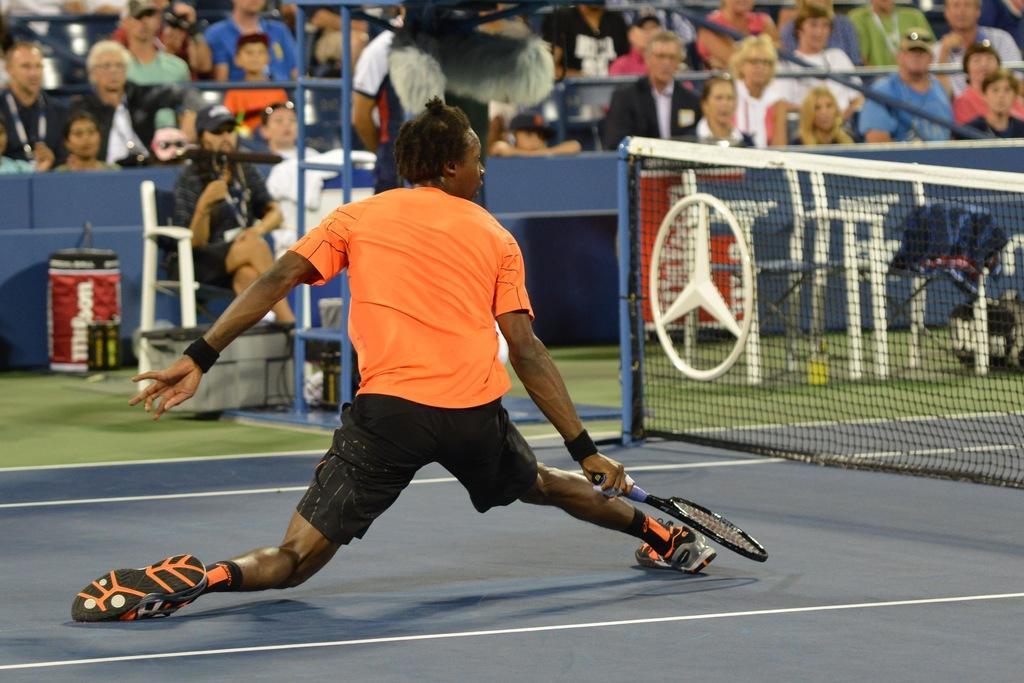Could you give a brief overview of what you see in this image? In this image, we can see people wearing clothes. There is a person in the middle of the image holding a racket with his hand. There is an another person on the left side of the image sitting on chair. There is a metal frame at the top of the image. There is an object in front of the wall. There is a net on the right side of the image. 